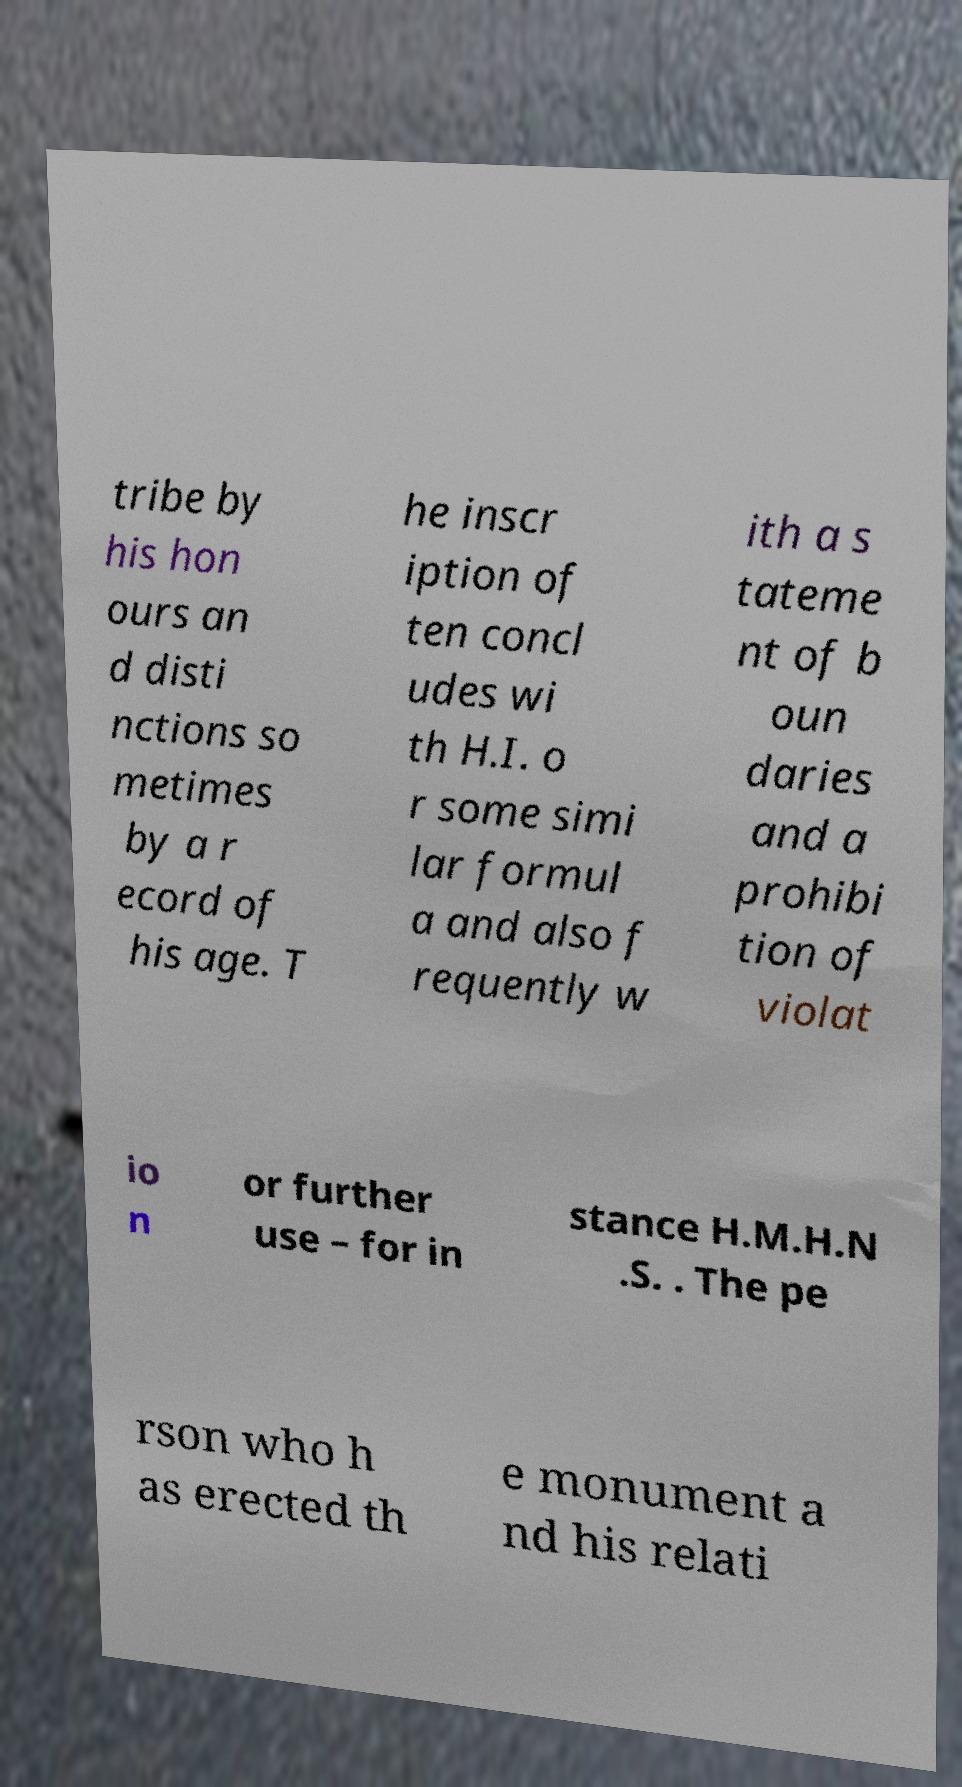Could you extract and type out the text from this image? tribe by his hon ours an d disti nctions so metimes by a r ecord of his age. T he inscr iption of ten concl udes wi th H.I. o r some simi lar formul a and also f requently w ith a s tateme nt of b oun daries and a prohibi tion of violat io n or further use – for in stance H.M.H.N .S. . The pe rson who h as erected th e monument a nd his relati 